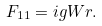Convert formula to latex. <formula><loc_0><loc_0><loc_500><loc_500>F _ { 1 1 } = i g W r .</formula> 